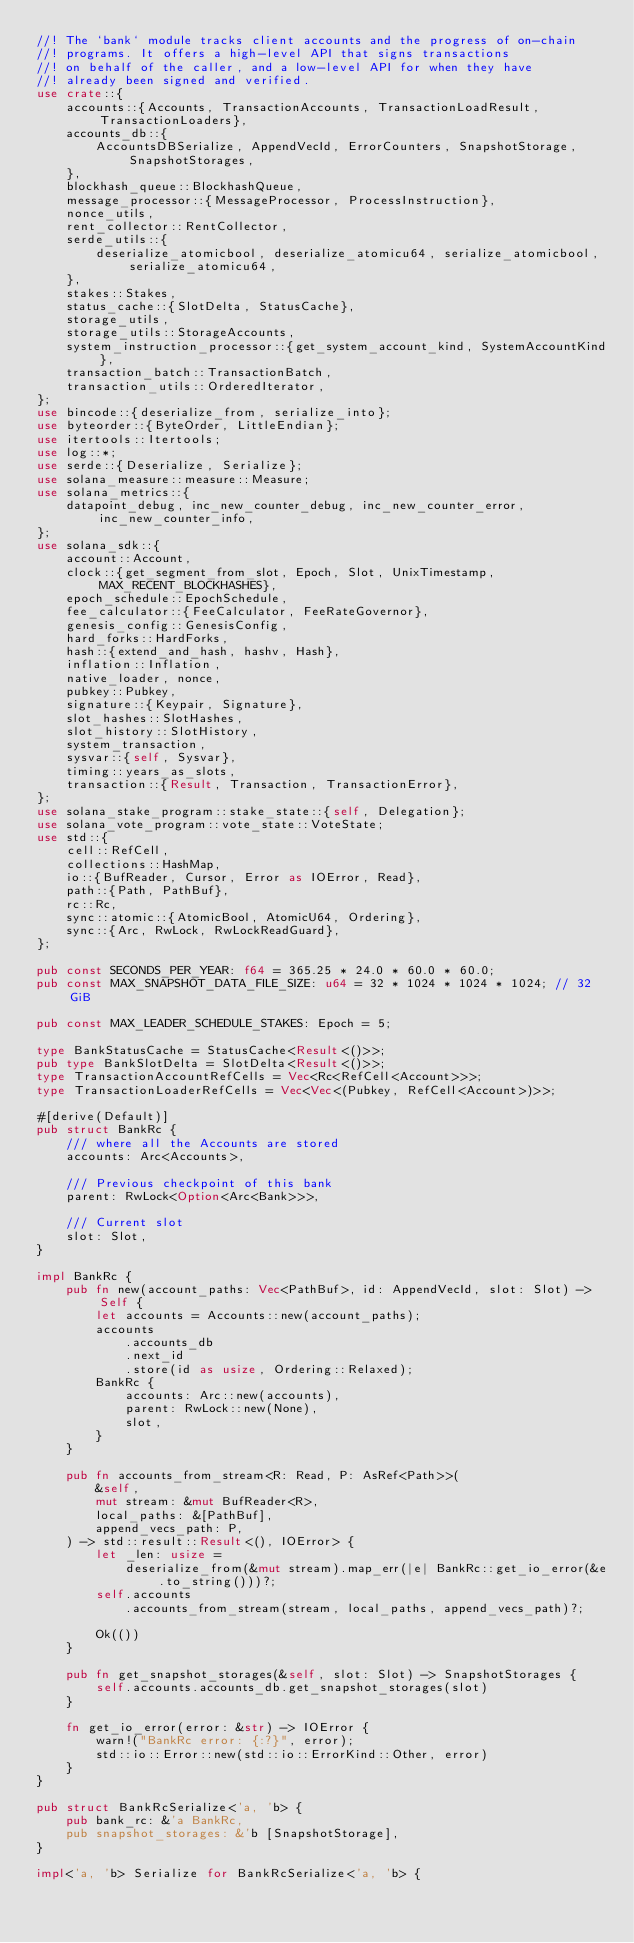Convert code to text. <code><loc_0><loc_0><loc_500><loc_500><_Rust_>//! The `bank` module tracks client accounts and the progress of on-chain
//! programs. It offers a high-level API that signs transactions
//! on behalf of the caller, and a low-level API for when they have
//! already been signed and verified.
use crate::{
    accounts::{Accounts, TransactionAccounts, TransactionLoadResult, TransactionLoaders},
    accounts_db::{
        AccountsDBSerialize, AppendVecId, ErrorCounters, SnapshotStorage, SnapshotStorages,
    },
    blockhash_queue::BlockhashQueue,
    message_processor::{MessageProcessor, ProcessInstruction},
    nonce_utils,
    rent_collector::RentCollector,
    serde_utils::{
        deserialize_atomicbool, deserialize_atomicu64, serialize_atomicbool, serialize_atomicu64,
    },
    stakes::Stakes,
    status_cache::{SlotDelta, StatusCache},
    storage_utils,
    storage_utils::StorageAccounts,
    system_instruction_processor::{get_system_account_kind, SystemAccountKind},
    transaction_batch::TransactionBatch,
    transaction_utils::OrderedIterator,
};
use bincode::{deserialize_from, serialize_into};
use byteorder::{ByteOrder, LittleEndian};
use itertools::Itertools;
use log::*;
use serde::{Deserialize, Serialize};
use solana_measure::measure::Measure;
use solana_metrics::{
    datapoint_debug, inc_new_counter_debug, inc_new_counter_error, inc_new_counter_info,
};
use solana_sdk::{
    account::Account,
    clock::{get_segment_from_slot, Epoch, Slot, UnixTimestamp, MAX_RECENT_BLOCKHASHES},
    epoch_schedule::EpochSchedule,
    fee_calculator::{FeeCalculator, FeeRateGovernor},
    genesis_config::GenesisConfig,
    hard_forks::HardForks,
    hash::{extend_and_hash, hashv, Hash},
    inflation::Inflation,
    native_loader, nonce,
    pubkey::Pubkey,
    signature::{Keypair, Signature},
    slot_hashes::SlotHashes,
    slot_history::SlotHistory,
    system_transaction,
    sysvar::{self, Sysvar},
    timing::years_as_slots,
    transaction::{Result, Transaction, TransactionError},
};
use solana_stake_program::stake_state::{self, Delegation};
use solana_vote_program::vote_state::VoteState;
use std::{
    cell::RefCell,
    collections::HashMap,
    io::{BufReader, Cursor, Error as IOError, Read},
    path::{Path, PathBuf},
    rc::Rc,
    sync::atomic::{AtomicBool, AtomicU64, Ordering},
    sync::{Arc, RwLock, RwLockReadGuard},
};

pub const SECONDS_PER_YEAR: f64 = 365.25 * 24.0 * 60.0 * 60.0;
pub const MAX_SNAPSHOT_DATA_FILE_SIZE: u64 = 32 * 1024 * 1024 * 1024; // 32 GiB

pub const MAX_LEADER_SCHEDULE_STAKES: Epoch = 5;

type BankStatusCache = StatusCache<Result<()>>;
pub type BankSlotDelta = SlotDelta<Result<()>>;
type TransactionAccountRefCells = Vec<Rc<RefCell<Account>>>;
type TransactionLoaderRefCells = Vec<Vec<(Pubkey, RefCell<Account>)>>;

#[derive(Default)]
pub struct BankRc {
    /// where all the Accounts are stored
    accounts: Arc<Accounts>,

    /// Previous checkpoint of this bank
    parent: RwLock<Option<Arc<Bank>>>,

    /// Current slot
    slot: Slot,
}

impl BankRc {
    pub fn new(account_paths: Vec<PathBuf>, id: AppendVecId, slot: Slot) -> Self {
        let accounts = Accounts::new(account_paths);
        accounts
            .accounts_db
            .next_id
            .store(id as usize, Ordering::Relaxed);
        BankRc {
            accounts: Arc::new(accounts),
            parent: RwLock::new(None),
            slot,
        }
    }

    pub fn accounts_from_stream<R: Read, P: AsRef<Path>>(
        &self,
        mut stream: &mut BufReader<R>,
        local_paths: &[PathBuf],
        append_vecs_path: P,
    ) -> std::result::Result<(), IOError> {
        let _len: usize =
            deserialize_from(&mut stream).map_err(|e| BankRc::get_io_error(&e.to_string()))?;
        self.accounts
            .accounts_from_stream(stream, local_paths, append_vecs_path)?;

        Ok(())
    }

    pub fn get_snapshot_storages(&self, slot: Slot) -> SnapshotStorages {
        self.accounts.accounts_db.get_snapshot_storages(slot)
    }

    fn get_io_error(error: &str) -> IOError {
        warn!("BankRc error: {:?}", error);
        std::io::Error::new(std::io::ErrorKind::Other, error)
    }
}

pub struct BankRcSerialize<'a, 'b> {
    pub bank_rc: &'a BankRc,
    pub snapshot_storages: &'b [SnapshotStorage],
}

impl<'a, 'b> Serialize for BankRcSerialize<'a, 'b> {</code> 